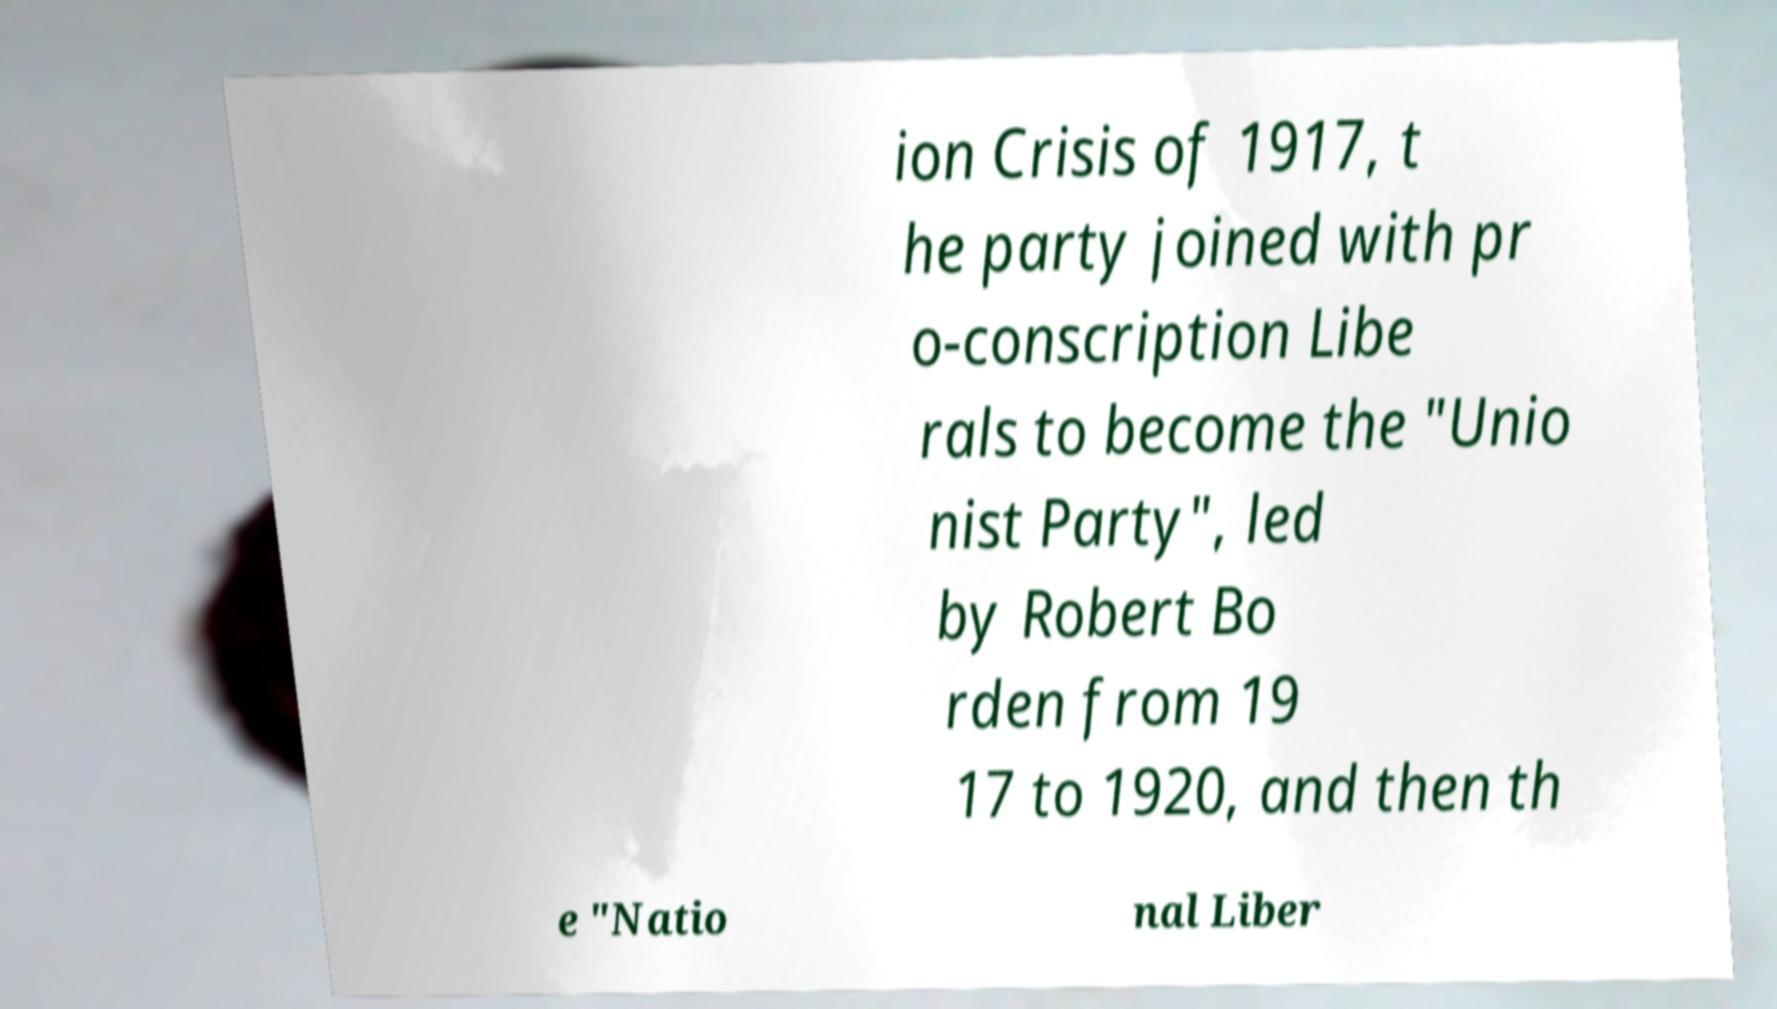There's text embedded in this image that I need extracted. Can you transcribe it verbatim? ion Crisis of 1917, t he party joined with pr o-conscription Libe rals to become the "Unio nist Party", led by Robert Bo rden from 19 17 to 1920, and then th e "Natio nal Liber 